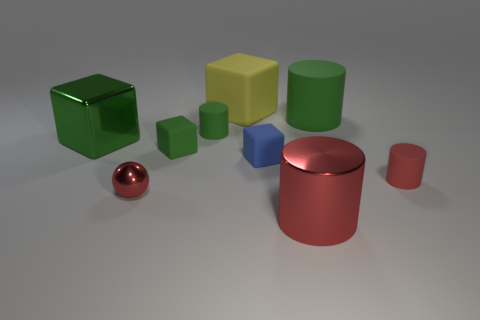There is a large thing that is the same color as the small sphere; what is it made of?
Your answer should be compact. Metal. Does the metallic cube have the same color as the big rubber cylinder?
Offer a very short reply. Yes. There is a small cube that is behind the small blue rubber object; what is it made of?
Make the answer very short. Rubber. What is the small green thing that is to the left of the small rubber cylinder left of the big green thing that is on the right side of the big yellow cube made of?
Your answer should be very brief. Rubber. What number of other objects are the same color as the large shiny block?
Offer a very short reply. 3. How many big purple cubes have the same material as the blue object?
Make the answer very short. 0. Do the big cylinder behind the green shiny cube and the large metallic block have the same color?
Keep it short and to the point. Yes. How many red objects are big rubber blocks or big matte things?
Provide a short and direct response. 0. Is the large cylinder that is behind the blue matte object made of the same material as the small blue cube?
Provide a succinct answer. Yes. What number of objects are small matte cylinders or things that are in front of the large matte block?
Offer a very short reply. 8. 